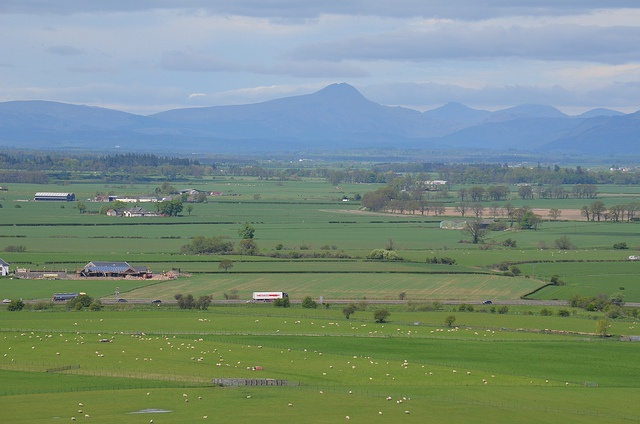Describe the objects in this image and their specific colors. I can see sheep in darkgray and olive tones, truck in darkgray, lightgray, gray, and lightpink tones, car in darkgray, gray, and black tones, car in darkgray, black, gray, and darkblue tones, and car in darkgray, gray, navy, darkblue, and black tones in this image. 